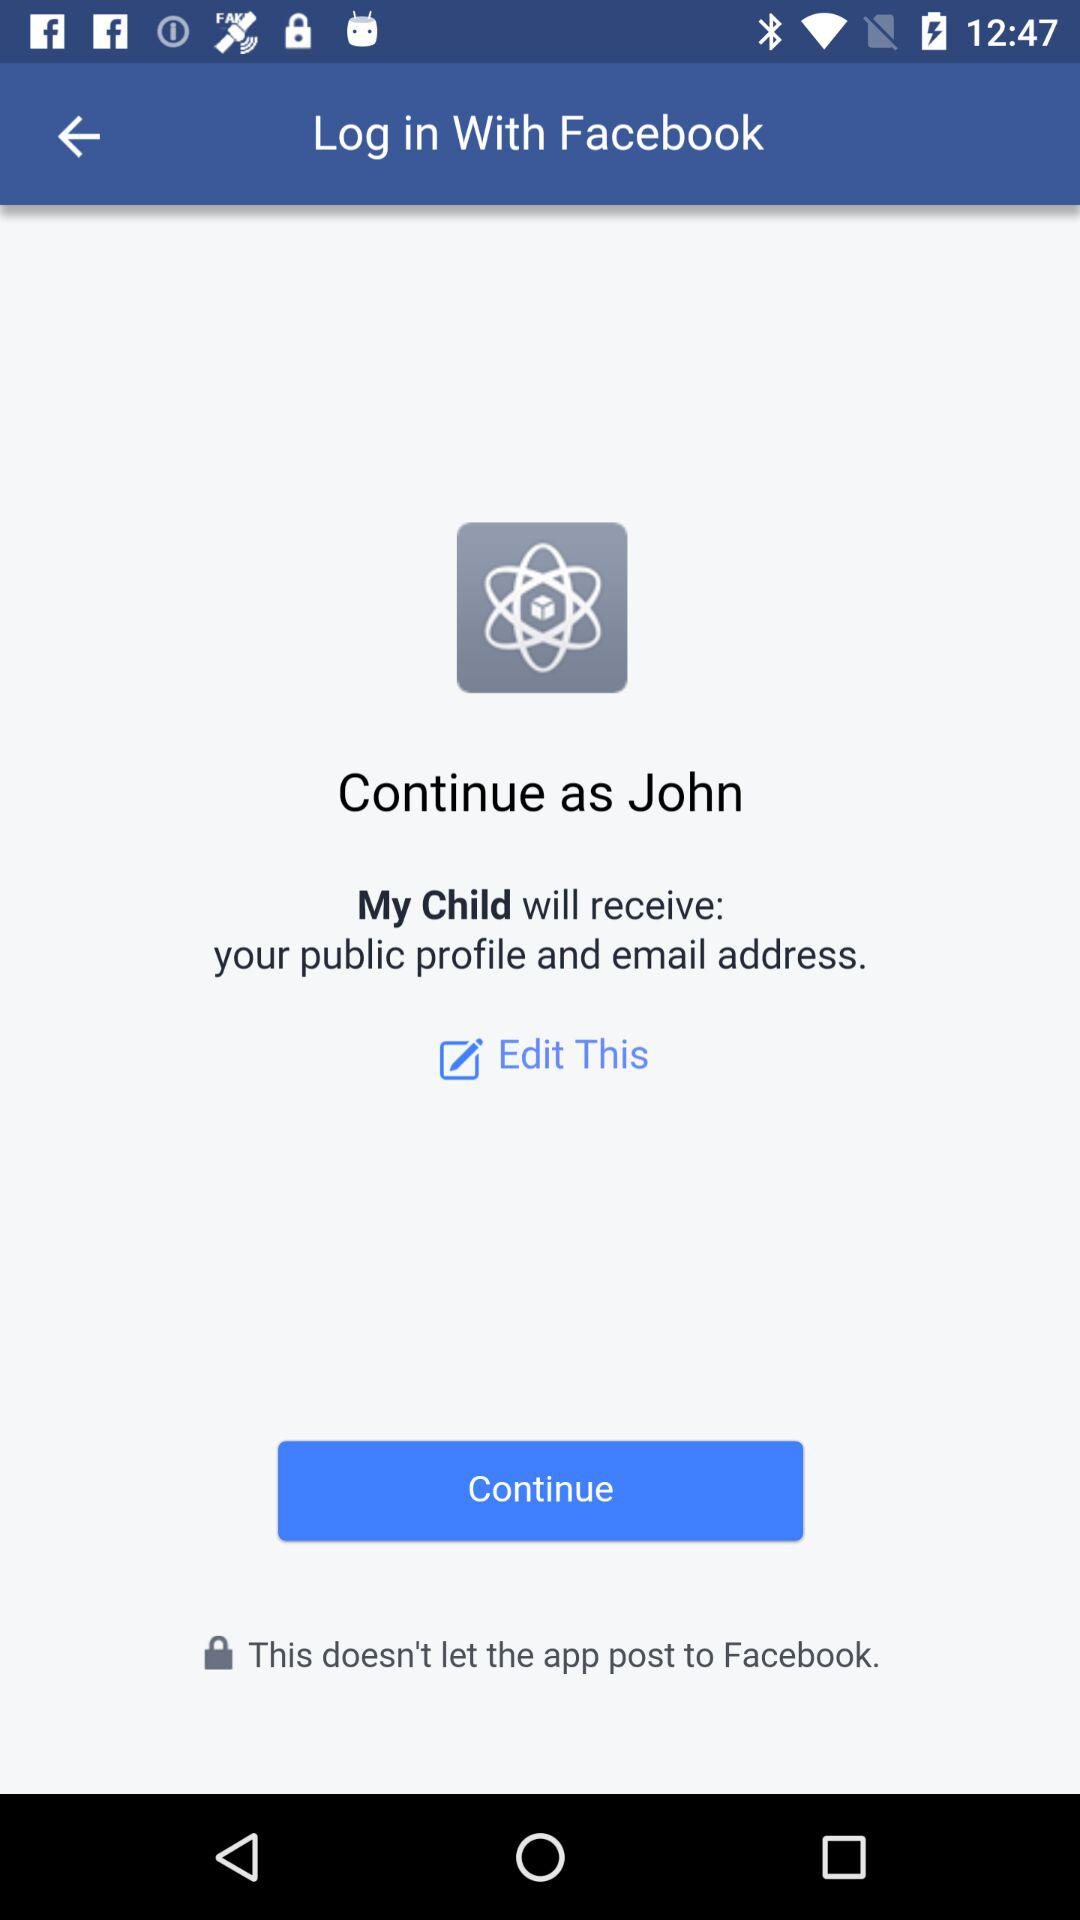What application can be used to log in? To log in, "Facebook" can be used. 